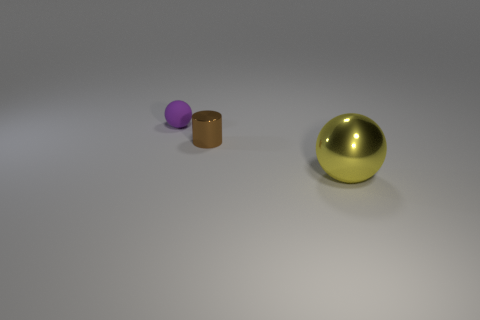Is the size of the yellow metallic object the same as the purple ball?
Provide a succinct answer. No. How many other cylinders are the same size as the cylinder?
Ensure brevity in your answer.  0. Is the material of the ball that is in front of the matte thing the same as the small object in front of the purple matte ball?
Offer a terse response. Yes. Is there anything else that has the same shape as the tiny shiny thing?
Offer a terse response. No. The tiny shiny object has what color?
Make the answer very short. Brown. What number of matte objects have the same shape as the big metal object?
Offer a very short reply. 1. What is the color of the other thing that is the same size as the brown thing?
Give a very brief answer. Purple. Are there any small green shiny cubes?
Ensure brevity in your answer.  No. What is the shape of the thing that is behind the tiny cylinder?
Offer a terse response. Sphere. What number of spheres are both behind the large metallic sphere and right of the rubber ball?
Your answer should be compact. 0. 